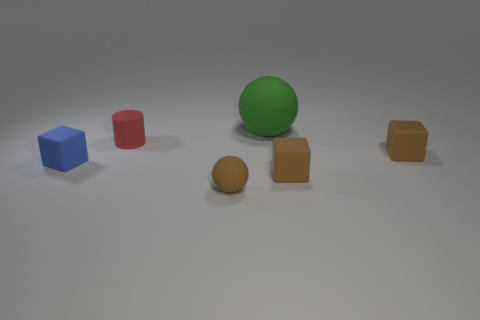Is there any other thing that is the same size as the green rubber thing?
Offer a very short reply. No. Is there any other thing that has the same shape as the red thing?
Provide a short and direct response. No. There is a tiny cylinder; is it the same color as the small matte cube that is on the left side of the matte cylinder?
Ensure brevity in your answer.  No. Are the blue block and the ball behind the tiny brown rubber ball made of the same material?
Offer a terse response. Yes. The ball that is behind the brown matte object that is on the left side of the big green sphere is made of what material?
Provide a short and direct response. Rubber. Are there more things behind the big ball than tiny brown things?
Ensure brevity in your answer.  No. Is there a gray thing?
Provide a short and direct response. No. The matte object on the left side of the small red object is what color?
Make the answer very short. Blue. There is a sphere that is the same size as the blue matte block; what material is it?
Give a very brief answer. Rubber. How many other things are the same material as the small cylinder?
Give a very brief answer. 5. 